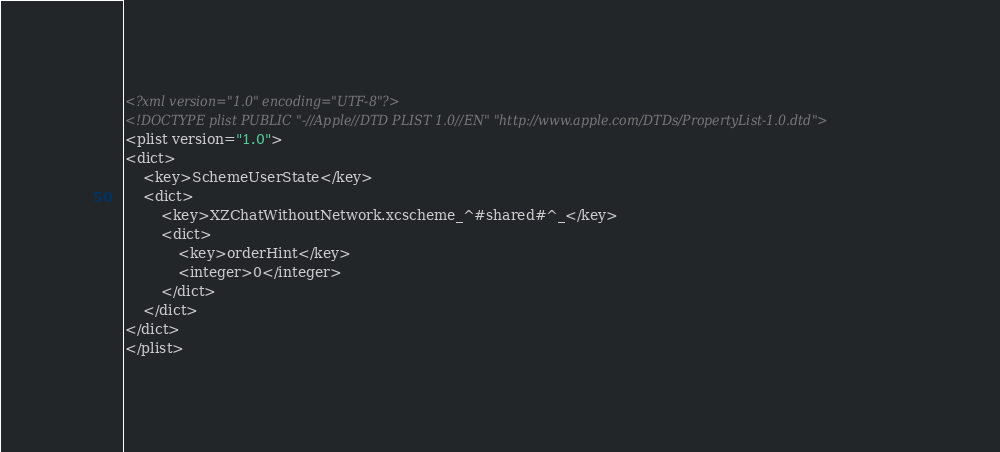Convert code to text. <code><loc_0><loc_0><loc_500><loc_500><_XML_><?xml version="1.0" encoding="UTF-8"?>
<!DOCTYPE plist PUBLIC "-//Apple//DTD PLIST 1.0//EN" "http://www.apple.com/DTDs/PropertyList-1.0.dtd">
<plist version="1.0">
<dict>
	<key>SchemeUserState</key>
	<dict>
		<key>XZChatWithoutNetwork.xcscheme_^#shared#^_</key>
		<dict>
			<key>orderHint</key>
			<integer>0</integer>
		</dict>
	</dict>
</dict>
</plist>
</code> 